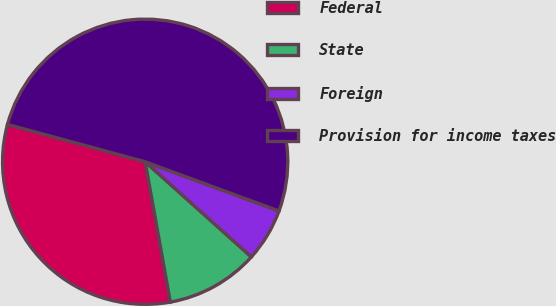<chart> <loc_0><loc_0><loc_500><loc_500><pie_chart><fcel>Federal<fcel>State<fcel>Foreign<fcel>Provision for income taxes<nl><fcel>32.04%<fcel>10.55%<fcel>6.01%<fcel>51.4%<nl></chart> 